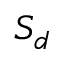Convert formula to latex. <formula><loc_0><loc_0><loc_500><loc_500>S _ { d }</formula> 